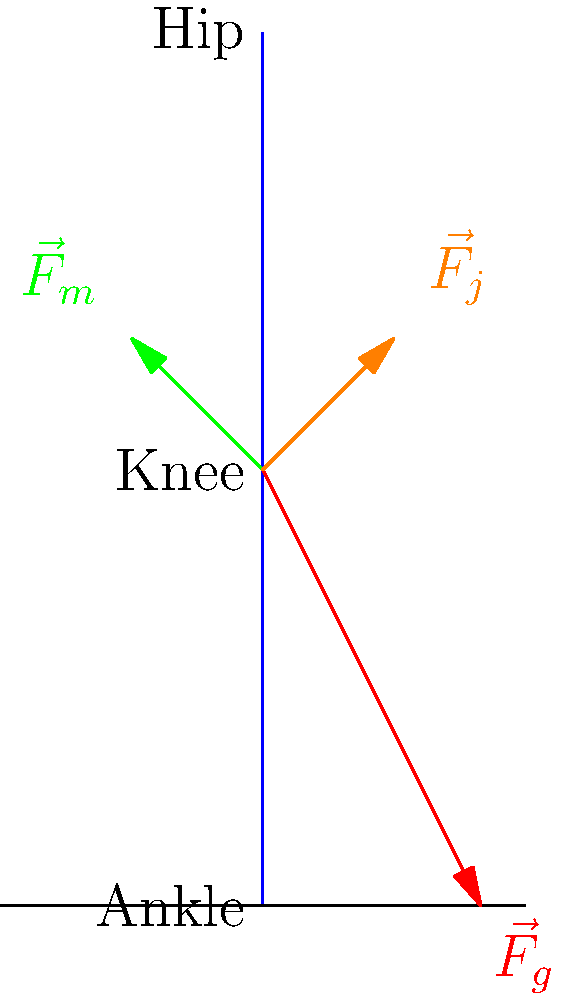In the biomechanical model of a squat exercise shown above, $\vec{F}_g$ represents the ground reaction force, $\vec{F}_m$ represents the muscle force, and $\vec{F}_j$ represents the joint reaction force at the knee. Using the principle of static equilibrium, which equation correctly represents the relationship between these forces? To solve this problem, we need to apply the principle of static equilibrium to the knee joint. The steps are as follows:

1) In static equilibrium, the sum of all forces acting on a point must equal zero.

2) In this case, we have three forces acting on the knee joint: 
   - Ground reaction force ($\vec{F}_g$)
   - Muscle force ($\vec{F}_m$)
   - Joint reaction force ($\vec{F}_j$)

3) The vector sum of these forces must equal zero:

   $$\vec{F}_g + \vec{F}_m + \vec{F}_j = 0$$

4) Rearranging this equation to solve for the joint reaction force:

   $$\vec{F}_j = -(\vec{F}_g + \vec{F}_m)$$

5) This equation states that the joint reaction force is equal and opposite to the sum of the ground reaction force and the muscle force.

6) In vector notation, this can be written as:

   $$\vec{F}_j = -\vec{F}_g - \vec{F}_m$$

This equation allows us to estimate the joint reaction force at the knee during a squat exercise, given the ground reaction force and muscle force.
Answer: $\vec{F}_j = -(\vec{F}_g + \vec{F}_m)$ 